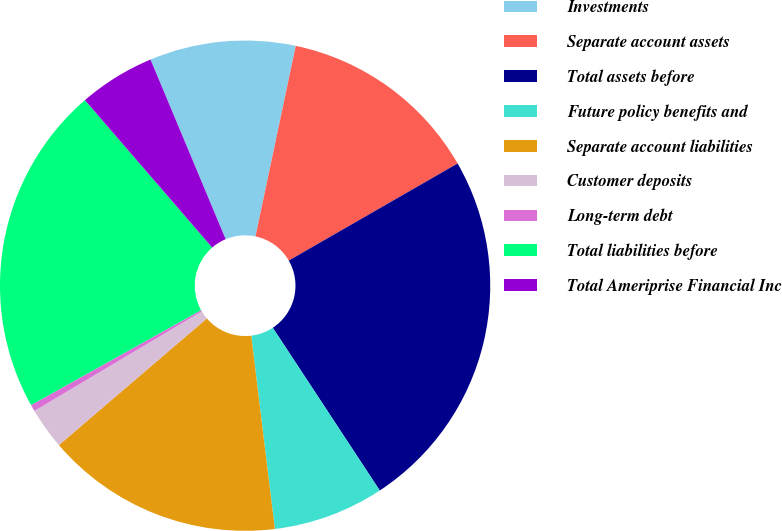Convert chart to OTSL. <chart><loc_0><loc_0><loc_500><loc_500><pie_chart><fcel>Investments<fcel>Separate account assets<fcel>Total assets before<fcel>Future policy benefits and<fcel>Separate account liabilities<fcel>Customer deposits<fcel>Long-term debt<fcel>Total liabilities before<fcel>Total Ameriprise Financial Inc<nl><fcel>9.62%<fcel>13.38%<fcel>24.05%<fcel>7.32%<fcel>15.67%<fcel>2.73%<fcel>0.44%<fcel>21.76%<fcel>5.03%<nl></chart> 